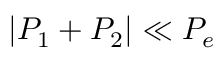<formula> <loc_0><loc_0><loc_500><loc_500>| P _ { 1 } + P _ { 2 } | \ll P _ { e }</formula> 